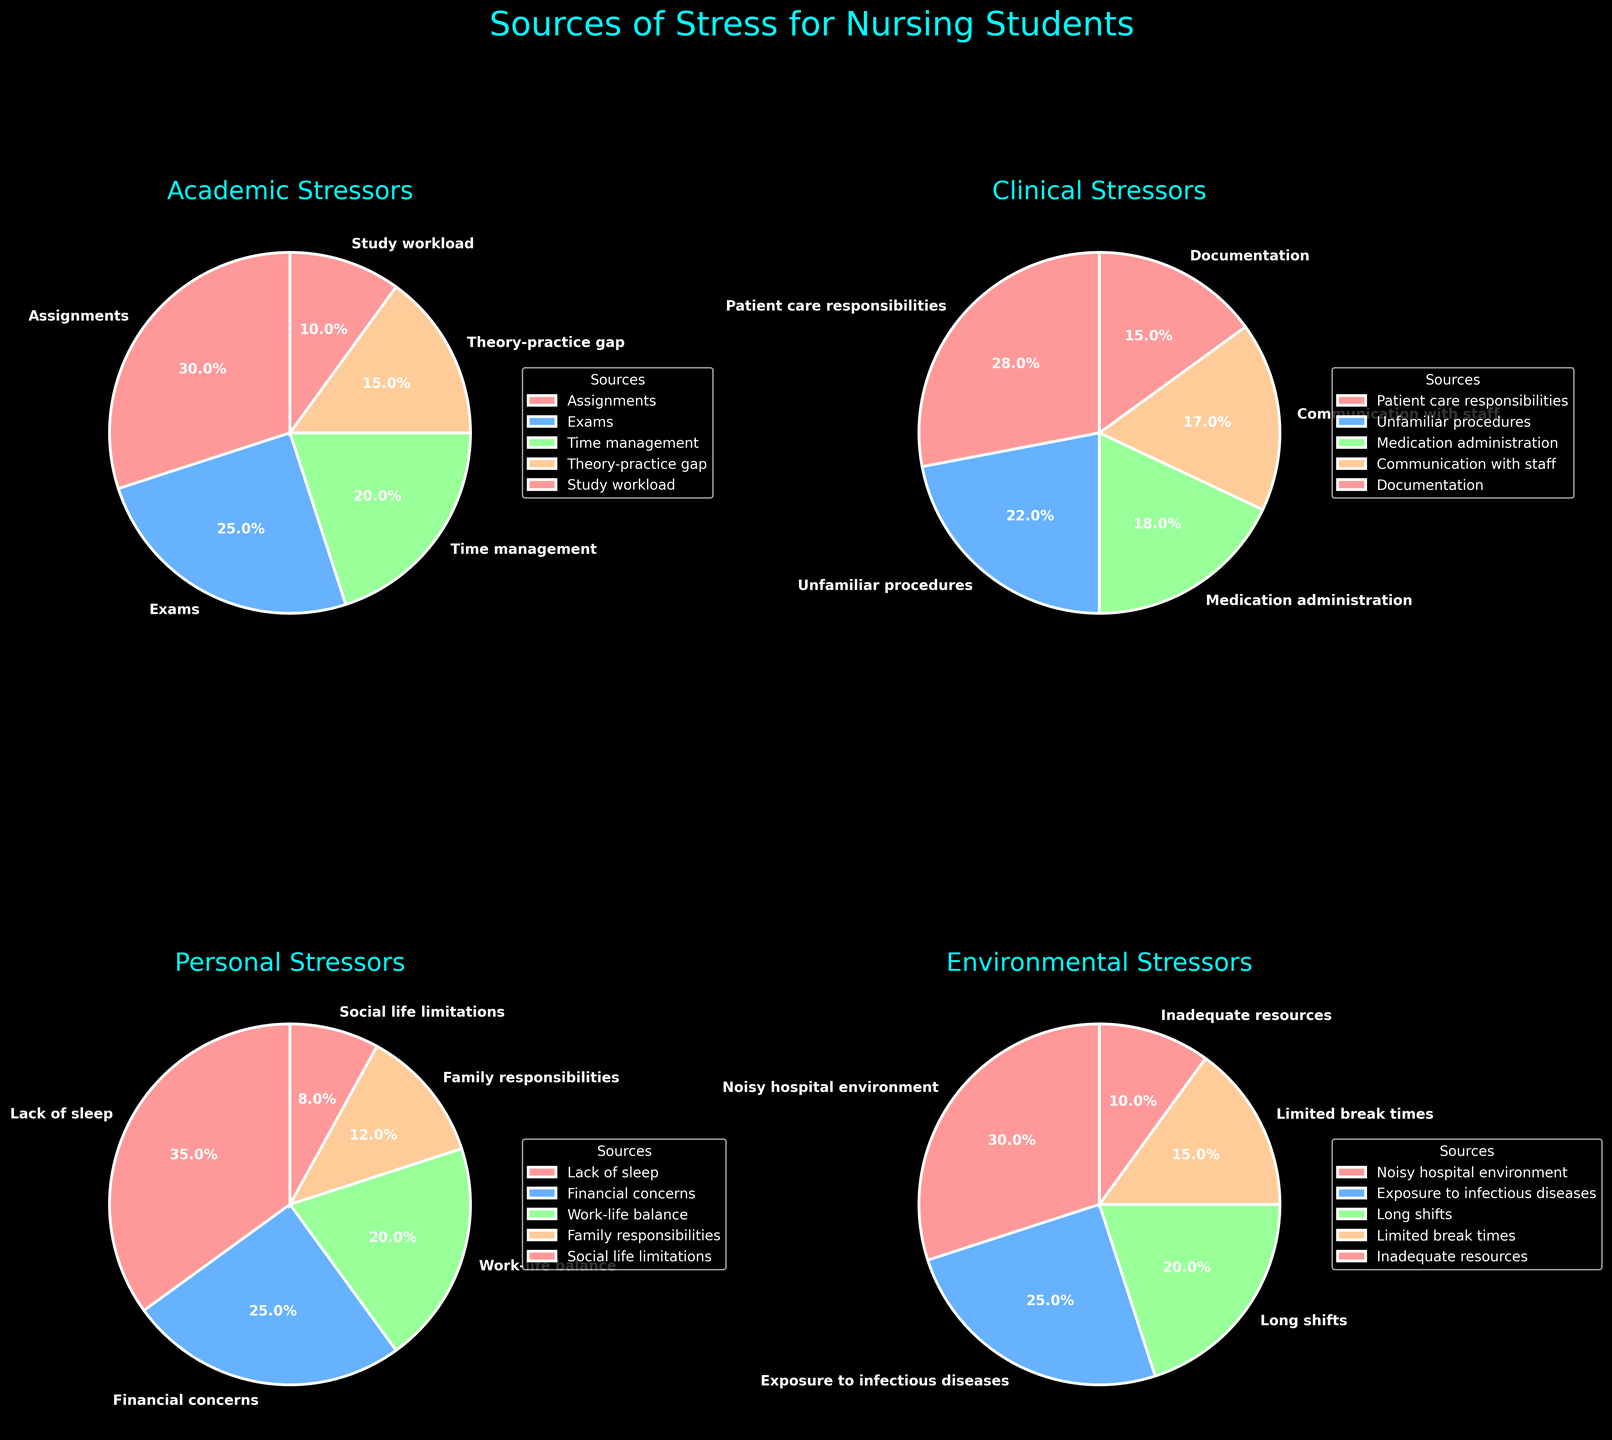What is the most reported academic stressor? Look at the pie chart for Academic Stressors and find the section with the largest percentage. The largest slice is labeled "Assignments" with a percentage of 30%.
Answer: Assignments What is the combined percentage of financial concerns and work-life balance for personal stressors? Add the percentages of "Financial concerns" (25%) and "Work-life balance" (20%) from the Personal Stressors pie chart. 25% + 20% = 45%.
Answer: 45% Which clinical stressor has the smallest percentage? Find the smallest slice in the Clinical Stressors pie chart. The smallest slice is labeled "Documentation" with a percentage of 15%.
Answer: Documentation If you sum up the percentages of patient care responsibilities and unfamiliar procedures, do they exceed the total percentage of academic stressors due to exams and time management? Add the percentages of "Patient care responsibilities" (28%) and "Unfamiliar procedures" (22%), which is 28% + 22% = 50%. Add "Exams" (25%) and "Time management" (20%) from the Academic stressors, which is 25% + 20% = 45%. Compare the two sums: 50% > 45%.
Answer: Yes What color represents environmental stressors in the pie chart? Look at the legend or the wedges indicating the Environmental Stressors. The slices for Environmental Stressors are colored in a shade of sandy orange.
Answer: Sandy orange Which category has higher stress due to long shifts: Clinical or Environmental? Compare "Long shifts" under Clinical (not listed) and Environmental stressors. "Long shifts" under Environmental stressors is 20%. Since there is no entry for "Long shifts" under Clinical, Environmental stressors have a higher percentage.
Answer: Environmental Compare the sources of stress due to lack of sleep and the exposure to infectious diseases. Which one has a higher reported percentage? Compare the slices from the Personal Stressors (Lack of sleep, 35%) and Environmental Stressors (Exposure to infectious diseases, 25%). Lack of sleep has a higher percentage.
Answer: Lack of sleep What is the total percentage of environmental stressors related to inadequate resources and limited break times? Add the percentages of "Inadequate resources" (10%) and "Limited break times" (15%) from the Environmental Stressors pie chart. 10% + 15% = 25%.
Answer: 25% Which specific academic stressor is contributing the least to stress among nursing students? Look at the Academic Stressors pie chart and find the smallest slice by percentage. The smallest slice is labeled "Study workload" with a percentage of 10%.
Answer: Study workload 